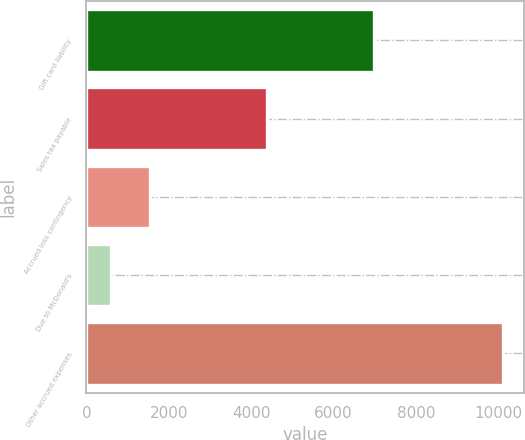Convert chart. <chart><loc_0><loc_0><loc_500><loc_500><bar_chart><fcel>Gift card liability<fcel>Sales tax payable<fcel>Accrued loss contingency<fcel>Due to McDonald's<fcel>Other accrued expenses<nl><fcel>6984<fcel>4381<fcel>1541.2<fcel>589<fcel>10111<nl></chart> 